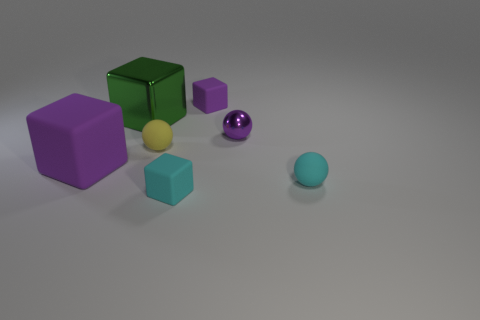Subtract all cyan cubes. How many cubes are left? 3 Add 4 tiny cyan matte spheres. How many tiny cyan matte spheres are left? 5 Add 5 tiny things. How many tiny things exist? 10 Add 1 rubber balls. How many objects exist? 8 Subtract all yellow balls. How many balls are left? 2 Subtract 0 blue balls. How many objects are left? 7 Subtract all spheres. How many objects are left? 4 Subtract 2 spheres. How many spheres are left? 1 Subtract all brown blocks. Subtract all brown cylinders. How many blocks are left? 4 Subtract all cyan cylinders. How many yellow spheres are left? 1 